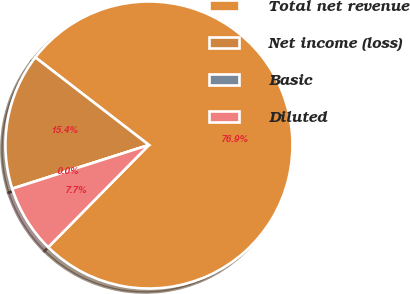Convert chart to OTSL. <chart><loc_0><loc_0><loc_500><loc_500><pie_chart><fcel>Total net revenue<fcel>Net income (loss)<fcel>Basic<fcel>Diluted<nl><fcel>76.92%<fcel>15.38%<fcel>0.0%<fcel>7.69%<nl></chart> 